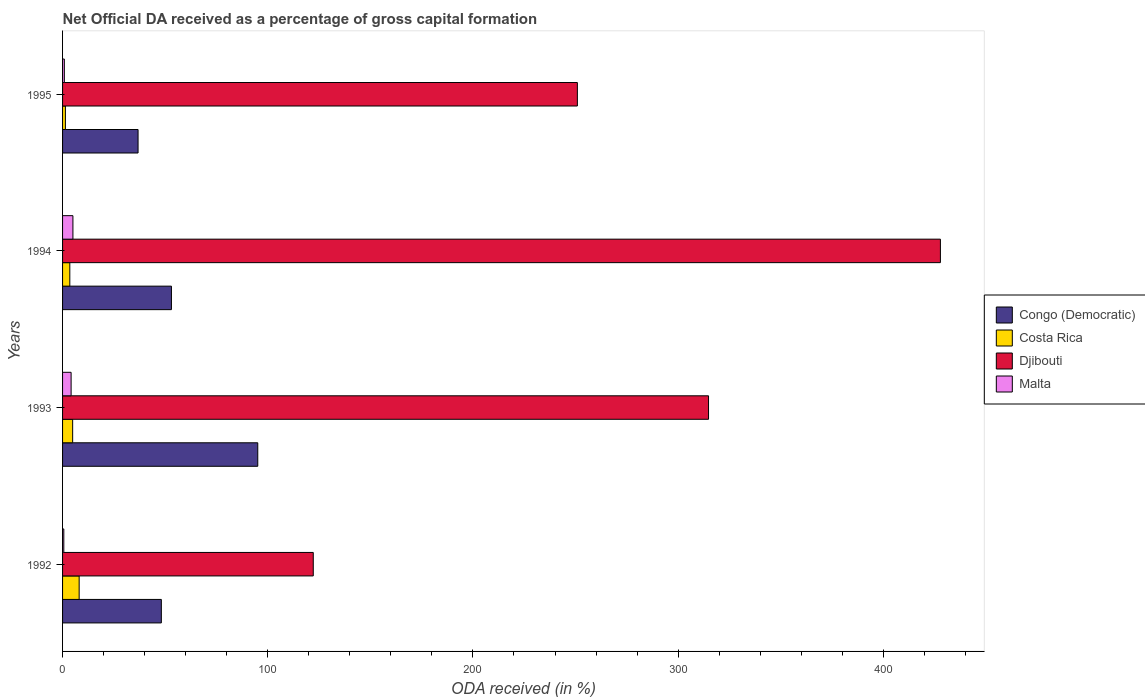What is the net ODA received in Djibouti in 1992?
Your answer should be very brief. 122.18. Across all years, what is the maximum net ODA received in Malta?
Your response must be concise. 5.04. Across all years, what is the minimum net ODA received in Costa Rica?
Your answer should be very brief. 1.39. What is the total net ODA received in Costa Rica in the graph?
Your answer should be very brief. 17.92. What is the difference between the net ODA received in Congo (Democratic) in 1992 and that in 1995?
Ensure brevity in your answer.  11.35. What is the difference between the net ODA received in Djibouti in 1994 and the net ODA received in Congo (Democratic) in 1995?
Your response must be concise. 391.02. What is the average net ODA received in Djibouti per year?
Make the answer very short. 278.92. In the year 1994, what is the difference between the net ODA received in Djibouti and net ODA received in Malta?
Give a very brief answer. 422.77. In how many years, is the net ODA received in Malta greater than 360 %?
Give a very brief answer. 0. What is the ratio of the net ODA received in Costa Rica in 1994 to that in 1995?
Ensure brevity in your answer.  2.54. Is the net ODA received in Djibouti in 1993 less than that in 1995?
Provide a short and direct response. No. Is the difference between the net ODA received in Djibouti in 1993 and 1994 greater than the difference between the net ODA received in Malta in 1993 and 1994?
Ensure brevity in your answer.  No. What is the difference between the highest and the second highest net ODA received in Malta?
Provide a short and direct response. 0.88. What is the difference between the highest and the lowest net ODA received in Congo (Democratic)?
Give a very brief answer. 58.34. In how many years, is the net ODA received in Congo (Democratic) greater than the average net ODA received in Congo (Democratic) taken over all years?
Your response must be concise. 1. Is it the case that in every year, the sum of the net ODA received in Congo (Democratic) and net ODA received in Costa Rica is greater than the sum of net ODA received in Djibouti and net ODA received in Malta?
Ensure brevity in your answer.  Yes. What does the 2nd bar from the top in 1995 represents?
Ensure brevity in your answer.  Djibouti. What does the 1st bar from the bottom in 1992 represents?
Your answer should be very brief. Congo (Democratic). Is it the case that in every year, the sum of the net ODA received in Djibouti and net ODA received in Congo (Democratic) is greater than the net ODA received in Malta?
Offer a very short reply. Yes. Are all the bars in the graph horizontal?
Offer a terse response. Yes. Are the values on the major ticks of X-axis written in scientific E-notation?
Give a very brief answer. No. Does the graph contain any zero values?
Your answer should be very brief. No. Where does the legend appear in the graph?
Provide a short and direct response. Center right. What is the title of the graph?
Give a very brief answer. Net Official DA received as a percentage of gross capital formation. What is the label or title of the X-axis?
Offer a terse response. ODA received (in %). What is the label or title of the Y-axis?
Give a very brief answer. Years. What is the ODA received (in %) in Congo (Democratic) in 1992?
Keep it short and to the point. 48.14. What is the ODA received (in %) of Costa Rica in 1992?
Your response must be concise. 8.09. What is the ODA received (in %) of Djibouti in 1992?
Offer a terse response. 122.18. What is the ODA received (in %) in Malta in 1992?
Provide a short and direct response. 0.61. What is the ODA received (in %) in Congo (Democratic) in 1993?
Provide a succinct answer. 95.13. What is the ODA received (in %) in Costa Rica in 1993?
Provide a short and direct response. 4.92. What is the ODA received (in %) in Djibouti in 1993?
Offer a very short reply. 314.81. What is the ODA received (in %) of Malta in 1993?
Offer a terse response. 4.16. What is the ODA received (in %) in Congo (Democratic) in 1994?
Offer a terse response. 53.06. What is the ODA received (in %) in Costa Rica in 1994?
Give a very brief answer. 3.53. What is the ODA received (in %) of Djibouti in 1994?
Offer a terse response. 427.81. What is the ODA received (in %) in Malta in 1994?
Your answer should be compact. 5.04. What is the ODA received (in %) of Congo (Democratic) in 1995?
Provide a succinct answer. 36.79. What is the ODA received (in %) of Costa Rica in 1995?
Offer a terse response. 1.39. What is the ODA received (in %) in Djibouti in 1995?
Your answer should be compact. 250.89. What is the ODA received (in %) of Malta in 1995?
Give a very brief answer. 0.86. Across all years, what is the maximum ODA received (in %) of Congo (Democratic)?
Provide a short and direct response. 95.13. Across all years, what is the maximum ODA received (in %) of Costa Rica?
Make the answer very short. 8.09. Across all years, what is the maximum ODA received (in %) in Djibouti?
Offer a very short reply. 427.81. Across all years, what is the maximum ODA received (in %) of Malta?
Offer a terse response. 5.04. Across all years, what is the minimum ODA received (in %) in Congo (Democratic)?
Your answer should be compact. 36.79. Across all years, what is the minimum ODA received (in %) of Costa Rica?
Your answer should be compact. 1.39. Across all years, what is the minimum ODA received (in %) in Djibouti?
Ensure brevity in your answer.  122.18. Across all years, what is the minimum ODA received (in %) in Malta?
Ensure brevity in your answer.  0.61. What is the total ODA received (in %) of Congo (Democratic) in the graph?
Provide a succinct answer. 233.12. What is the total ODA received (in %) of Costa Rica in the graph?
Your answer should be very brief. 17.92. What is the total ODA received (in %) of Djibouti in the graph?
Offer a very short reply. 1115.69. What is the total ODA received (in %) in Malta in the graph?
Your answer should be compact. 10.68. What is the difference between the ODA received (in %) of Congo (Democratic) in 1992 and that in 1993?
Give a very brief answer. -46.99. What is the difference between the ODA received (in %) in Costa Rica in 1992 and that in 1993?
Give a very brief answer. 3.17. What is the difference between the ODA received (in %) in Djibouti in 1992 and that in 1993?
Provide a short and direct response. -192.63. What is the difference between the ODA received (in %) in Malta in 1992 and that in 1993?
Make the answer very short. -3.56. What is the difference between the ODA received (in %) of Congo (Democratic) in 1992 and that in 1994?
Provide a short and direct response. -4.92. What is the difference between the ODA received (in %) in Costa Rica in 1992 and that in 1994?
Your answer should be compact. 4.55. What is the difference between the ODA received (in %) of Djibouti in 1992 and that in 1994?
Give a very brief answer. -305.63. What is the difference between the ODA received (in %) of Malta in 1992 and that in 1994?
Ensure brevity in your answer.  -4.44. What is the difference between the ODA received (in %) of Congo (Democratic) in 1992 and that in 1995?
Give a very brief answer. 11.35. What is the difference between the ODA received (in %) of Costa Rica in 1992 and that in 1995?
Offer a terse response. 6.7. What is the difference between the ODA received (in %) of Djibouti in 1992 and that in 1995?
Ensure brevity in your answer.  -128.71. What is the difference between the ODA received (in %) in Malta in 1992 and that in 1995?
Ensure brevity in your answer.  -0.26. What is the difference between the ODA received (in %) of Congo (Democratic) in 1993 and that in 1994?
Keep it short and to the point. 42.07. What is the difference between the ODA received (in %) of Costa Rica in 1993 and that in 1994?
Keep it short and to the point. 1.39. What is the difference between the ODA received (in %) in Djibouti in 1993 and that in 1994?
Make the answer very short. -113. What is the difference between the ODA received (in %) in Malta in 1993 and that in 1994?
Keep it short and to the point. -0.88. What is the difference between the ODA received (in %) of Congo (Democratic) in 1993 and that in 1995?
Offer a terse response. 58.34. What is the difference between the ODA received (in %) in Costa Rica in 1993 and that in 1995?
Provide a succinct answer. 3.53. What is the difference between the ODA received (in %) of Djibouti in 1993 and that in 1995?
Your answer should be compact. 63.92. What is the difference between the ODA received (in %) in Malta in 1993 and that in 1995?
Your response must be concise. 3.3. What is the difference between the ODA received (in %) in Congo (Democratic) in 1994 and that in 1995?
Your answer should be compact. 16.27. What is the difference between the ODA received (in %) of Costa Rica in 1994 and that in 1995?
Provide a short and direct response. 2.14. What is the difference between the ODA received (in %) in Djibouti in 1994 and that in 1995?
Offer a very short reply. 176.93. What is the difference between the ODA received (in %) in Malta in 1994 and that in 1995?
Provide a short and direct response. 4.18. What is the difference between the ODA received (in %) of Congo (Democratic) in 1992 and the ODA received (in %) of Costa Rica in 1993?
Offer a very short reply. 43.22. What is the difference between the ODA received (in %) of Congo (Democratic) in 1992 and the ODA received (in %) of Djibouti in 1993?
Your answer should be compact. -266.67. What is the difference between the ODA received (in %) of Congo (Democratic) in 1992 and the ODA received (in %) of Malta in 1993?
Offer a terse response. 43.98. What is the difference between the ODA received (in %) of Costa Rica in 1992 and the ODA received (in %) of Djibouti in 1993?
Your answer should be very brief. -306.73. What is the difference between the ODA received (in %) in Costa Rica in 1992 and the ODA received (in %) in Malta in 1993?
Ensure brevity in your answer.  3.92. What is the difference between the ODA received (in %) of Djibouti in 1992 and the ODA received (in %) of Malta in 1993?
Offer a very short reply. 118.02. What is the difference between the ODA received (in %) of Congo (Democratic) in 1992 and the ODA received (in %) of Costa Rica in 1994?
Make the answer very short. 44.61. What is the difference between the ODA received (in %) in Congo (Democratic) in 1992 and the ODA received (in %) in Djibouti in 1994?
Keep it short and to the point. -379.67. What is the difference between the ODA received (in %) of Congo (Democratic) in 1992 and the ODA received (in %) of Malta in 1994?
Your answer should be compact. 43.1. What is the difference between the ODA received (in %) of Costa Rica in 1992 and the ODA received (in %) of Djibouti in 1994?
Offer a very short reply. -419.73. What is the difference between the ODA received (in %) of Costa Rica in 1992 and the ODA received (in %) of Malta in 1994?
Provide a succinct answer. 3.04. What is the difference between the ODA received (in %) in Djibouti in 1992 and the ODA received (in %) in Malta in 1994?
Your answer should be compact. 117.14. What is the difference between the ODA received (in %) of Congo (Democratic) in 1992 and the ODA received (in %) of Costa Rica in 1995?
Your answer should be very brief. 46.75. What is the difference between the ODA received (in %) in Congo (Democratic) in 1992 and the ODA received (in %) in Djibouti in 1995?
Your answer should be very brief. -202.75. What is the difference between the ODA received (in %) in Congo (Democratic) in 1992 and the ODA received (in %) in Malta in 1995?
Offer a terse response. 47.28. What is the difference between the ODA received (in %) of Costa Rica in 1992 and the ODA received (in %) of Djibouti in 1995?
Your answer should be compact. -242.8. What is the difference between the ODA received (in %) in Costa Rica in 1992 and the ODA received (in %) in Malta in 1995?
Give a very brief answer. 7.22. What is the difference between the ODA received (in %) of Djibouti in 1992 and the ODA received (in %) of Malta in 1995?
Give a very brief answer. 121.32. What is the difference between the ODA received (in %) of Congo (Democratic) in 1993 and the ODA received (in %) of Costa Rica in 1994?
Give a very brief answer. 91.6. What is the difference between the ODA received (in %) in Congo (Democratic) in 1993 and the ODA received (in %) in Djibouti in 1994?
Ensure brevity in your answer.  -332.68. What is the difference between the ODA received (in %) of Congo (Democratic) in 1993 and the ODA received (in %) of Malta in 1994?
Keep it short and to the point. 90.09. What is the difference between the ODA received (in %) of Costa Rica in 1993 and the ODA received (in %) of Djibouti in 1994?
Offer a terse response. -422.9. What is the difference between the ODA received (in %) of Costa Rica in 1993 and the ODA received (in %) of Malta in 1994?
Make the answer very short. -0.13. What is the difference between the ODA received (in %) in Djibouti in 1993 and the ODA received (in %) in Malta in 1994?
Your response must be concise. 309.77. What is the difference between the ODA received (in %) in Congo (Democratic) in 1993 and the ODA received (in %) in Costa Rica in 1995?
Your answer should be compact. 93.74. What is the difference between the ODA received (in %) of Congo (Democratic) in 1993 and the ODA received (in %) of Djibouti in 1995?
Offer a very short reply. -155.76. What is the difference between the ODA received (in %) in Congo (Democratic) in 1993 and the ODA received (in %) in Malta in 1995?
Your response must be concise. 94.27. What is the difference between the ODA received (in %) of Costa Rica in 1993 and the ODA received (in %) of Djibouti in 1995?
Keep it short and to the point. -245.97. What is the difference between the ODA received (in %) of Costa Rica in 1993 and the ODA received (in %) of Malta in 1995?
Provide a succinct answer. 4.05. What is the difference between the ODA received (in %) of Djibouti in 1993 and the ODA received (in %) of Malta in 1995?
Keep it short and to the point. 313.95. What is the difference between the ODA received (in %) of Congo (Democratic) in 1994 and the ODA received (in %) of Costa Rica in 1995?
Your answer should be very brief. 51.67. What is the difference between the ODA received (in %) of Congo (Democratic) in 1994 and the ODA received (in %) of Djibouti in 1995?
Your answer should be very brief. -197.83. What is the difference between the ODA received (in %) of Congo (Democratic) in 1994 and the ODA received (in %) of Malta in 1995?
Give a very brief answer. 52.19. What is the difference between the ODA received (in %) in Costa Rica in 1994 and the ODA received (in %) in Djibouti in 1995?
Your response must be concise. -247.36. What is the difference between the ODA received (in %) of Costa Rica in 1994 and the ODA received (in %) of Malta in 1995?
Ensure brevity in your answer.  2.67. What is the difference between the ODA received (in %) of Djibouti in 1994 and the ODA received (in %) of Malta in 1995?
Ensure brevity in your answer.  426.95. What is the average ODA received (in %) in Congo (Democratic) per year?
Provide a succinct answer. 58.28. What is the average ODA received (in %) of Costa Rica per year?
Offer a terse response. 4.48. What is the average ODA received (in %) of Djibouti per year?
Keep it short and to the point. 278.92. What is the average ODA received (in %) of Malta per year?
Your response must be concise. 2.67. In the year 1992, what is the difference between the ODA received (in %) of Congo (Democratic) and ODA received (in %) of Costa Rica?
Ensure brevity in your answer.  40.05. In the year 1992, what is the difference between the ODA received (in %) in Congo (Democratic) and ODA received (in %) in Djibouti?
Provide a short and direct response. -74.04. In the year 1992, what is the difference between the ODA received (in %) in Congo (Democratic) and ODA received (in %) in Malta?
Your response must be concise. 47.53. In the year 1992, what is the difference between the ODA received (in %) in Costa Rica and ODA received (in %) in Djibouti?
Ensure brevity in your answer.  -114.09. In the year 1992, what is the difference between the ODA received (in %) in Costa Rica and ODA received (in %) in Malta?
Give a very brief answer. 7.48. In the year 1992, what is the difference between the ODA received (in %) of Djibouti and ODA received (in %) of Malta?
Offer a very short reply. 121.57. In the year 1993, what is the difference between the ODA received (in %) in Congo (Democratic) and ODA received (in %) in Costa Rica?
Provide a short and direct response. 90.21. In the year 1993, what is the difference between the ODA received (in %) in Congo (Democratic) and ODA received (in %) in Djibouti?
Provide a short and direct response. -219.68. In the year 1993, what is the difference between the ODA received (in %) of Congo (Democratic) and ODA received (in %) of Malta?
Keep it short and to the point. 90.97. In the year 1993, what is the difference between the ODA received (in %) of Costa Rica and ODA received (in %) of Djibouti?
Make the answer very short. -309.89. In the year 1993, what is the difference between the ODA received (in %) in Costa Rica and ODA received (in %) in Malta?
Offer a terse response. 0.76. In the year 1993, what is the difference between the ODA received (in %) in Djibouti and ODA received (in %) in Malta?
Ensure brevity in your answer.  310.65. In the year 1994, what is the difference between the ODA received (in %) in Congo (Democratic) and ODA received (in %) in Costa Rica?
Give a very brief answer. 49.53. In the year 1994, what is the difference between the ODA received (in %) in Congo (Democratic) and ODA received (in %) in Djibouti?
Your answer should be compact. -374.76. In the year 1994, what is the difference between the ODA received (in %) in Congo (Democratic) and ODA received (in %) in Malta?
Provide a short and direct response. 48.01. In the year 1994, what is the difference between the ODA received (in %) of Costa Rica and ODA received (in %) of Djibouti?
Make the answer very short. -424.28. In the year 1994, what is the difference between the ODA received (in %) in Costa Rica and ODA received (in %) in Malta?
Ensure brevity in your answer.  -1.51. In the year 1994, what is the difference between the ODA received (in %) in Djibouti and ODA received (in %) in Malta?
Ensure brevity in your answer.  422.77. In the year 1995, what is the difference between the ODA received (in %) in Congo (Democratic) and ODA received (in %) in Costa Rica?
Your answer should be compact. 35.4. In the year 1995, what is the difference between the ODA received (in %) of Congo (Democratic) and ODA received (in %) of Djibouti?
Ensure brevity in your answer.  -214.1. In the year 1995, what is the difference between the ODA received (in %) of Congo (Democratic) and ODA received (in %) of Malta?
Offer a very short reply. 35.93. In the year 1995, what is the difference between the ODA received (in %) of Costa Rica and ODA received (in %) of Djibouti?
Give a very brief answer. -249.5. In the year 1995, what is the difference between the ODA received (in %) of Costa Rica and ODA received (in %) of Malta?
Your answer should be very brief. 0.52. In the year 1995, what is the difference between the ODA received (in %) in Djibouti and ODA received (in %) in Malta?
Make the answer very short. 250.02. What is the ratio of the ODA received (in %) in Congo (Democratic) in 1992 to that in 1993?
Keep it short and to the point. 0.51. What is the ratio of the ODA received (in %) of Costa Rica in 1992 to that in 1993?
Ensure brevity in your answer.  1.64. What is the ratio of the ODA received (in %) of Djibouti in 1992 to that in 1993?
Offer a terse response. 0.39. What is the ratio of the ODA received (in %) of Malta in 1992 to that in 1993?
Provide a succinct answer. 0.15. What is the ratio of the ODA received (in %) of Congo (Democratic) in 1992 to that in 1994?
Offer a terse response. 0.91. What is the ratio of the ODA received (in %) of Costa Rica in 1992 to that in 1994?
Offer a terse response. 2.29. What is the ratio of the ODA received (in %) in Djibouti in 1992 to that in 1994?
Keep it short and to the point. 0.29. What is the ratio of the ODA received (in %) in Malta in 1992 to that in 1994?
Offer a terse response. 0.12. What is the ratio of the ODA received (in %) in Congo (Democratic) in 1992 to that in 1995?
Provide a short and direct response. 1.31. What is the ratio of the ODA received (in %) of Costa Rica in 1992 to that in 1995?
Provide a succinct answer. 5.83. What is the ratio of the ODA received (in %) in Djibouti in 1992 to that in 1995?
Your response must be concise. 0.49. What is the ratio of the ODA received (in %) of Malta in 1992 to that in 1995?
Your answer should be very brief. 0.7. What is the ratio of the ODA received (in %) of Congo (Democratic) in 1993 to that in 1994?
Keep it short and to the point. 1.79. What is the ratio of the ODA received (in %) in Costa Rica in 1993 to that in 1994?
Keep it short and to the point. 1.39. What is the ratio of the ODA received (in %) of Djibouti in 1993 to that in 1994?
Your answer should be very brief. 0.74. What is the ratio of the ODA received (in %) in Malta in 1993 to that in 1994?
Ensure brevity in your answer.  0.83. What is the ratio of the ODA received (in %) in Congo (Democratic) in 1993 to that in 1995?
Your answer should be very brief. 2.59. What is the ratio of the ODA received (in %) in Costa Rica in 1993 to that in 1995?
Ensure brevity in your answer.  3.54. What is the ratio of the ODA received (in %) of Djibouti in 1993 to that in 1995?
Your answer should be compact. 1.25. What is the ratio of the ODA received (in %) in Malta in 1993 to that in 1995?
Make the answer very short. 4.82. What is the ratio of the ODA received (in %) in Congo (Democratic) in 1994 to that in 1995?
Keep it short and to the point. 1.44. What is the ratio of the ODA received (in %) of Costa Rica in 1994 to that in 1995?
Ensure brevity in your answer.  2.54. What is the ratio of the ODA received (in %) in Djibouti in 1994 to that in 1995?
Provide a succinct answer. 1.71. What is the ratio of the ODA received (in %) of Malta in 1994 to that in 1995?
Your answer should be very brief. 5.84. What is the difference between the highest and the second highest ODA received (in %) of Congo (Democratic)?
Offer a terse response. 42.07. What is the difference between the highest and the second highest ODA received (in %) in Costa Rica?
Your response must be concise. 3.17. What is the difference between the highest and the second highest ODA received (in %) in Djibouti?
Ensure brevity in your answer.  113. What is the difference between the highest and the second highest ODA received (in %) in Malta?
Offer a very short reply. 0.88. What is the difference between the highest and the lowest ODA received (in %) in Congo (Democratic)?
Your answer should be very brief. 58.34. What is the difference between the highest and the lowest ODA received (in %) in Costa Rica?
Provide a short and direct response. 6.7. What is the difference between the highest and the lowest ODA received (in %) of Djibouti?
Your answer should be very brief. 305.63. What is the difference between the highest and the lowest ODA received (in %) of Malta?
Your answer should be very brief. 4.44. 